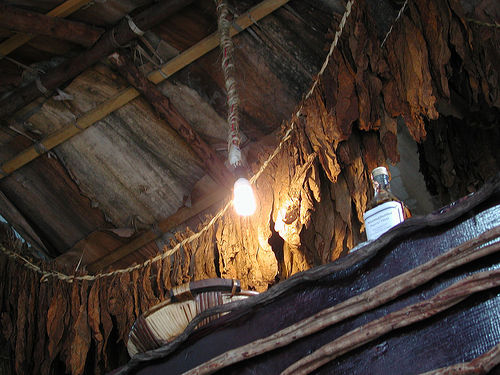<image>
Is there a wire in the bulb? No. The wire is not contained within the bulb. These objects have a different spatial relationship. 